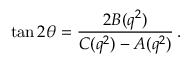<formula> <loc_0><loc_0><loc_500><loc_500>\tan 2 \theta = \frac { 2 B ( q ^ { 2 } ) } { C ( q ^ { 2 } ) - A ( q ^ { 2 } ) } \, .</formula> 